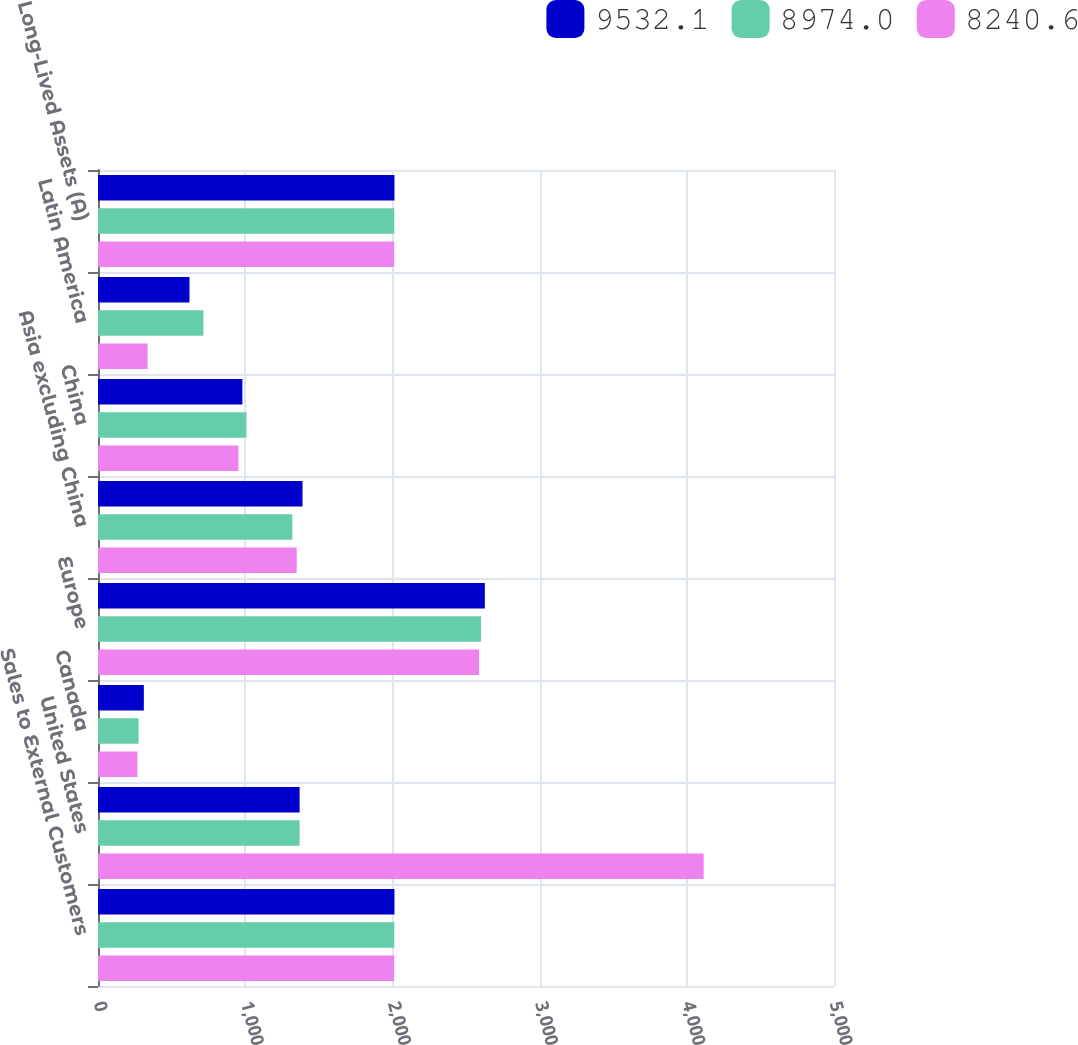Convert chart. <chart><loc_0><loc_0><loc_500><loc_500><stacked_bar_chart><ecel><fcel>Sales to External Customers<fcel>United States<fcel>Canada<fcel>Europe<fcel>Asia excluding China<fcel>China<fcel>Latin America<fcel>Long-Lived Assets (A)<nl><fcel>9532.1<fcel>2014<fcel>1369.65<fcel>311.4<fcel>2628<fcel>1389.4<fcel>981<fcel>621.6<fcel>2014<nl><fcel>8974<fcel>2013<fcel>1369.65<fcel>275.5<fcel>2602.1<fcel>1320.1<fcel>1008.3<fcel>716<fcel>2013<nl><fcel>8240.6<fcel>2012<fcel>4114.5<fcel>267.6<fcel>2588.5<fcel>1349.9<fcel>954.1<fcel>337.1<fcel>2012<nl></chart> 